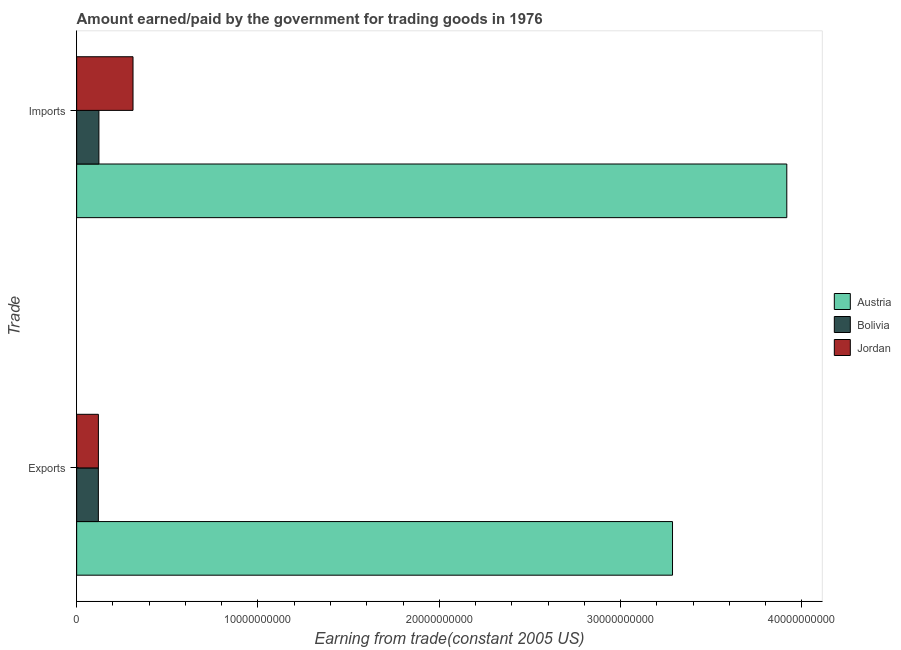How many groups of bars are there?
Give a very brief answer. 2. How many bars are there on the 1st tick from the bottom?
Offer a very short reply. 3. What is the label of the 1st group of bars from the top?
Your answer should be very brief. Imports. What is the amount earned from exports in Austria?
Provide a short and direct response. 3.29e+1. Across all countries, what is the maximum amount paid for imports?
Ensure brevity in your answer.  3.92e+1. Across all countries, what is the minimum amount paid for imports?
Provide a short and direct response. 1.23e+09. What is the total amount earned from exports in the graph?
Make the answer very short. 3.53e+1. What is the difference between the amount paid for imports in Jordan and that in Bolivia?
Keep it short and to the point. 1.88e+09. What is the difference between the amount earned from exports in Bolivia and the amount paid for imports in Jordan?
Give a very brief answer. -1.91e+09. What is the average amount paid for imports per country?
Keep it short and to the point. 1.45e+1. What is the difference between the amount earned from exports and amount paid for imports in Austria?
Give a very brief answer. -6.30e+09. In how many countries, is the amount paid for imports greater than 34000000000 US$?
Make the answer very short. 1. What is the ratio of the amount earned from exports in Bolivia to that in Jordan?
Your response must be concise. 1. Is the amount paid for imports in Bolivia less than that in Austria?
Offer a very short reply. Yes. What does the 1st bar from the top in Imports represents?
Provide a short and direct response. Jordan. Are all the bars in the graph horizontal?
Keep it short and to the point. Yes. How many countries are there in the graph?
Ensure brevity in your answer.  3. What is the difference between two consecutive major ticks on the X-axis?
Provide a succinct answer. 1.00e+1. How are the legend labels stacked?
Your answer should be very brief. Vertical. What is the title of the graph?
Your answer should be very brief. Amount earned/paid by the government for trading goods in 1976. What is the label or title of the X-axis?
Provide a short and direct response. Earning from trade(constant 2005 US). What is the label or title of the Y-axis?
Offer a terse response. Trade. What is the Earning from trade(constant 2005 US) in Austria in Exports?
Offer a very short reply. 3.29e+1. What is the Earning from trade(constant 2005 US) of Bolivia in Exports?
Make the answer very short. 1.20e+09. What is the Earning from trade(constant 2005 US) in Jordan in Exports?
Offer a terse response. 1.20e+09. What is the Earning from trade(constant 2005 US) of Austria in Imports?
Make the answer very short. 3.92e+1. What is the Earning from trade(constant 2005 US) of Bolivia in Imports?
Ensure brevity in your answer.  1.23e+09. What is the Earning from trade(constant 2005 US) of Jordan in Imports?
Offer a terse response. 3.11e+09. Across all Trade, what is the maximum Earning from trade(constant 2005 US) in Austria?
Your answer should be very brief. 3.92e+1. Across all Trade, what is the maximum Earning from trade(constant 2005 US) of Bolivia?
Make the answer very short. 1.23e+09. Across all Trade, what is the maximum Earning from trade(constant 2005 US) in Jordan?
Your answer should be very brief. 3.11e+09. Across all Trade, what is the minimum Earning from trade(constant 2005 US) in Austria?
Your answer should be very brief. 3.29e+1. Across all Trade, what is the minimum Earning from trade(constant 2005 US) of Bolivia?
Your answer should be compact. 1.20e+09. Across all Trade, what is the minimum Earning from trade(constant 2005 US) of Jordan?
Make the answer very short. 1.20e+09. What is the total Earning from trade(constant 2005 US) in Austria in the graph?
Your answer should be compact. 7.20e+1. What is the total Earning from trade(constant 2005 US) of Bolivia in the graph?
Provide a succinct answer. 2.42e+09. What is the total Earning from trade(constant 2005 US) in Jordan in the graph?
Offer a very short reply. 4.31e+09. What is the difference between the Earning from trade(constant 2005 US) of Austria in Exports and that in Imports?
Keep it short and to the point. -6.30e+09. What is the difference between the Earning from trade(constant 2005 US) of Bolivia in Exports and that in Imports?
Your response must be concise. -3.00e+07. What is the difference between the Earning from trade(constant 2005 US) of Jordan in Exports and that in Imports?
Provide a succinct answer. -1.91e+09. What is the difference between the Earning from trade(constant 2005 US) of Austria in Exports and the Earning from trade(constant 2005 US) of Bolivia in Imports?
Keep it short and to the point. 3.16e+1. What is the difference between the Earning from trade(constant 2005 US) of Austria in Exports and the Earning from trade(constant 2005 US) of Jordan in Imports?
Provide a succinct answer. 2.98e+1. What is the difference between the Earning from trade(constant 2005 US) of Bolivia in Exports and the Earning from trade(constant 2005 US) of Jordan in Imports?
Provide a succinct answer. -1.91e+09. What is the average Earning from trade(constant 2005 US) in Austria per Trade?
Your answer should be compact. 3.60e+1. What is the average Earning from trade(constant 2005 US) in Bolivia per Trade?
Provide a short and direct response. 1.21e+09. What is the average Earning from trade(constant 2005 US) of Jordan per Trade?
Offer a very short reply. 2.15e+09. What is the difference between the Earning from trade(constant 2005 US) in Austria and Earning from trade(constant 2005 US) in Bolivia in Exports?
Provide a succinct answer. 3.17e+1. What is the difference between the Earning from trade(constant 2005 US) of Austria and Earning from trade(constant 2005 US) of Jordan in Exports?
Offer a very short reply. 3.17e+1. What is the difference between the Earning from trade(constant 2005 US) in Bolivia and Earning from trade(constant 2005 US) in Jordan in Exports?
Keep it short and to the point. -1.93e+06. What is the difference between the Earning from trade(constant 2005 US) of Austria and Earning from trade(constant 2005 US) of Bolivia in Imports?
Make the answer very short. 3.79e+1. What is the difference between the Earning from trade(constant 2005 US) of Austria and Earning from trade(constant 2005 US) of Jordan in Imports?
Keep it short and to the point. 3.61e+1. What is the difference between the Earning from trade(constant 2005 US) of Bolivia and Earning from trade(constant 2005 US) of Jordan in Imports?
Give a very brief answer. -1.88e+09. What is the ratio of the Earning from trade(constant 2005 US) of Austria in Exports to that in Imports?
Offer a very short reply. 0.84. What is the ratio of the Earning from trade(constant 2005 US) in Bolivia in Exports to that in Imports?
Ensure brevity in your answer.  0.98. What is the ratio of the Earning from trade(constant 2005 US) of Jordan in Exports to that in Imports?
Ensure brevity in your answer.  0.39. What is the difference between the highest and the second highest Earning from trade(constant 2005 US) in Austria?
Provide a short and direct response. 6.30e+09. What is the difference between the highest and the second highest Earning from trade(constant 2005 US) in Bolivia?
Provide a short and direct response. 3.00e+07. What is the difference between the highest and the second highest Earning from trade(constant 2005 US) in Jordan?
Provide a succinct answer. 1.91e+09. What is the difference between the highest and the lowest Earning from trade(constant 2005 US) in Austria?
Offer a very short reply. 6.30e+09. What is the difference between the highest and the lowest Earning from trade(constant 2005 US) of Bolivia?
Make the answer very short. 3.00e+07. What is the difference between the highest and the lowest Earning from trade(constant 2005 US) in Jordan?
Keep it short and to the point. 1.91e+09. 